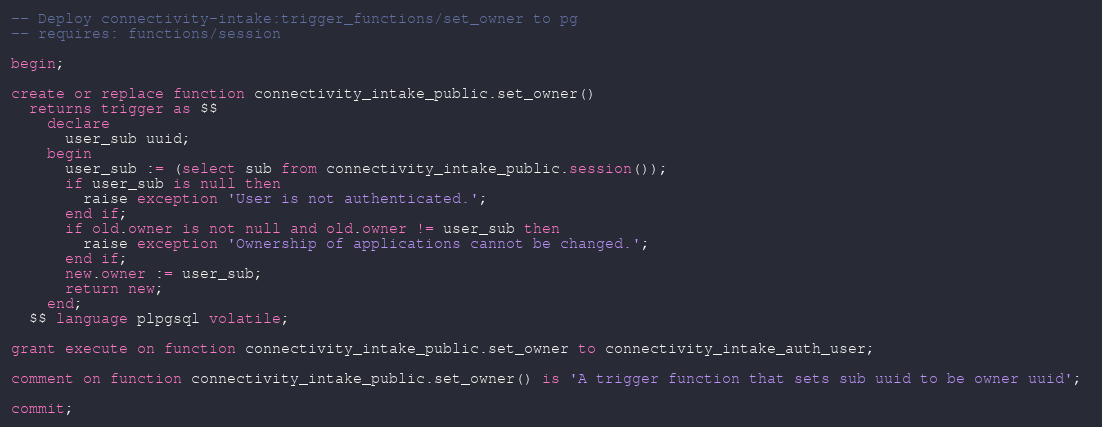<code> <loc_0><loc_0><loc_500><loc_500><_SQL_>-- Deploy connectivity-intake:trigger_functions/set_owner to pg
-- requires: functions/session

begin;

create or replace function connectivity_intake_public.set_owner()
  returns trigger as $$
    declare
      user_sub uuid;
    begin
      user_sub := (select sub from connectivity_intake_public.session());
      if user_sub is null then
        raise exception 'User is not authenticated.';
      end if;
      if old.owner is not null and old.owner != user_sub then
        raise exception 'Ownership of applications cannot be changed.';
      end if;
      new.owner := user_sub;
      return new;
    end;
  $$ language plpgsql volatile;

grant execute on function connectivity_intake_public.set_owner to connectivity_intake_auth_user;

comment on function connectivity_intake_public.set_owner() is 'A trigger function that sets sub uuid to be owner uuid'; 

commit;
</code> 